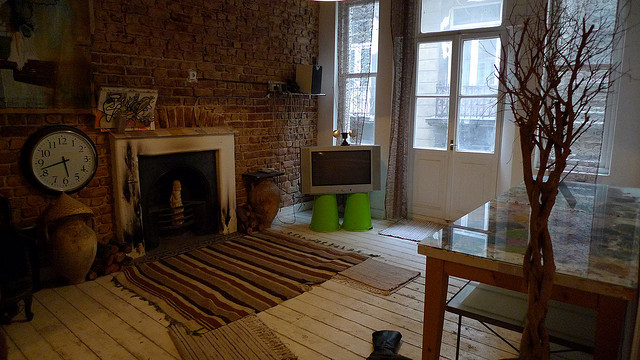What kind of plant do you see in this picture? There's a leafless tree that adds a sculptural element to the room. Its bare branches contribute to the aesthetic of the space, evoking a sense of natural simplicity and bringing an organic texture to the interior design. 